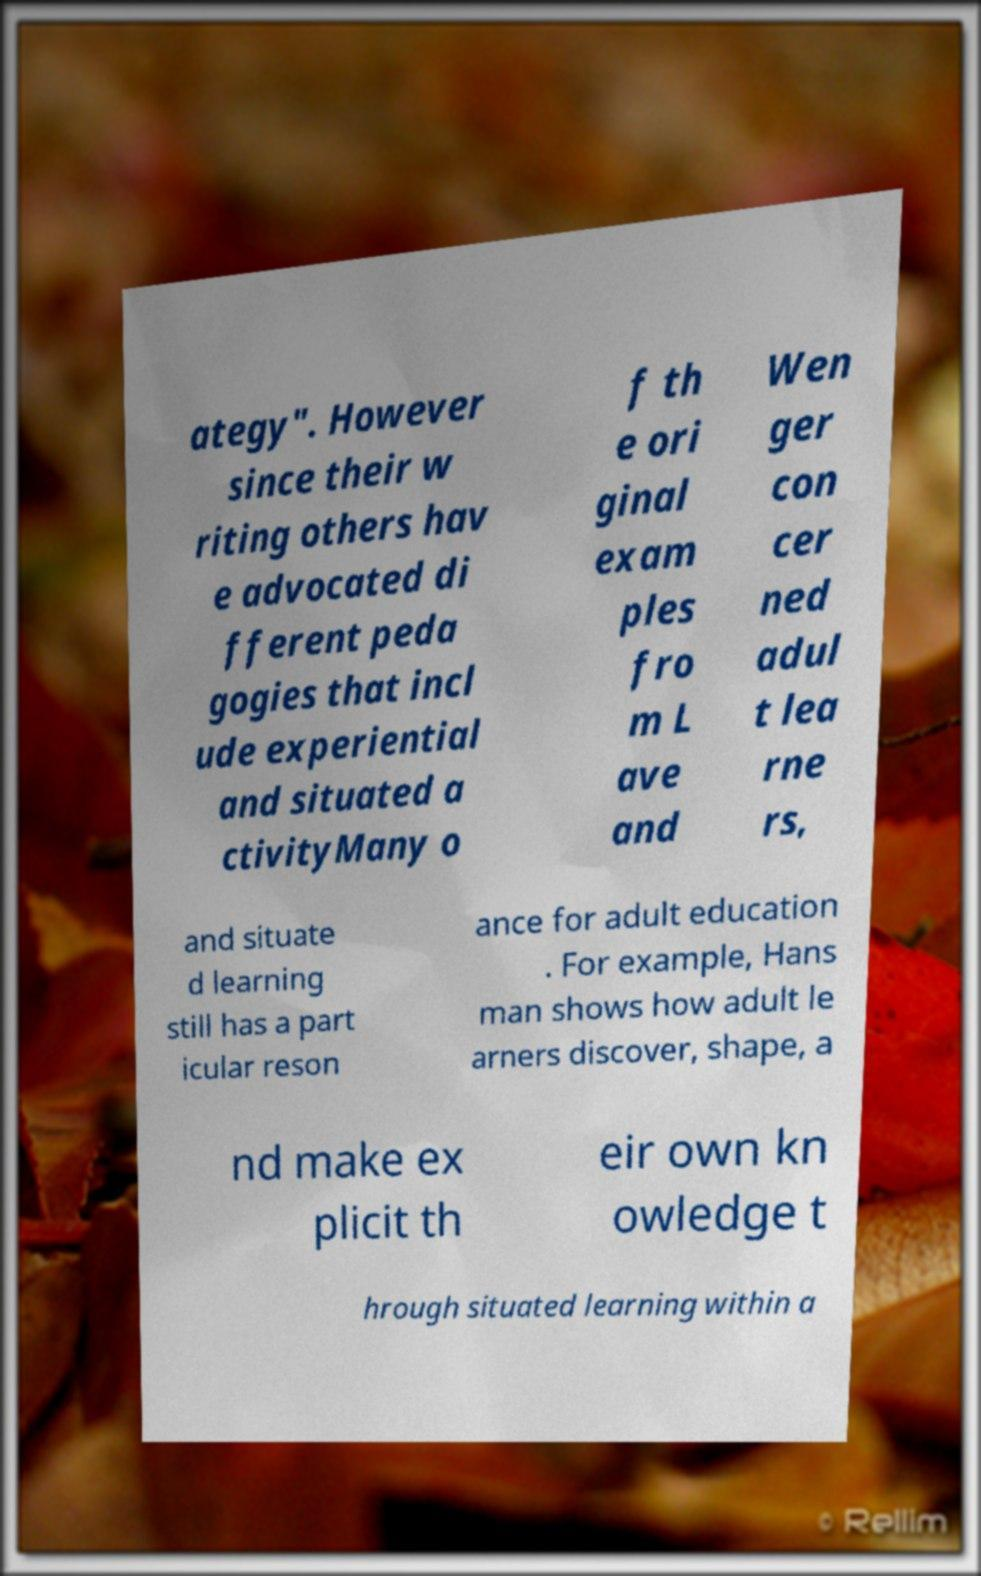Can you accurately transcribe the text from the provided image for me? ategy". However since their w riting others hav e advocated di fferent peda gogies that incl ude experiential and situated a ctivityMany o f th e ori ginal exam ples fro m L ave and Wen ger con cer ned adul t lea rne rs, and situate d learning still has a part icular reson ance for adult education . For example, Hans man shows how adult le arners discover, shape, a nd make ex plicit th eir own kn owledge t hrough situated learning within a 